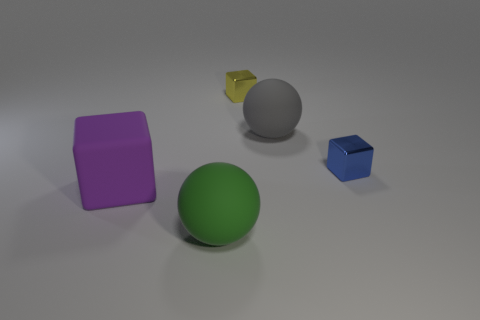Subtract all green spheres. How many spheres are left? 1 Subtract all tiny cubes. How many cubes are left? 1 Subtract 3 cubes. How many cubes are left? 0 Subtract all spheres. How many objects are left? 3 Add 1 purple things. How many objects exist? 6 Subtract all cyan cubes. How many cyan balls are left? 0 Add 1 big green metallic objects. How many big green metallic objects exist? 1 Subtract 0 blue spheres. How many objects are left? 5 Subtract all red cubes. Subtract all blue cylinders. How many cubes are left? 3 Subtract all big gray cylinders. Subtract all tiny metal objects. How many objects are left? 3 